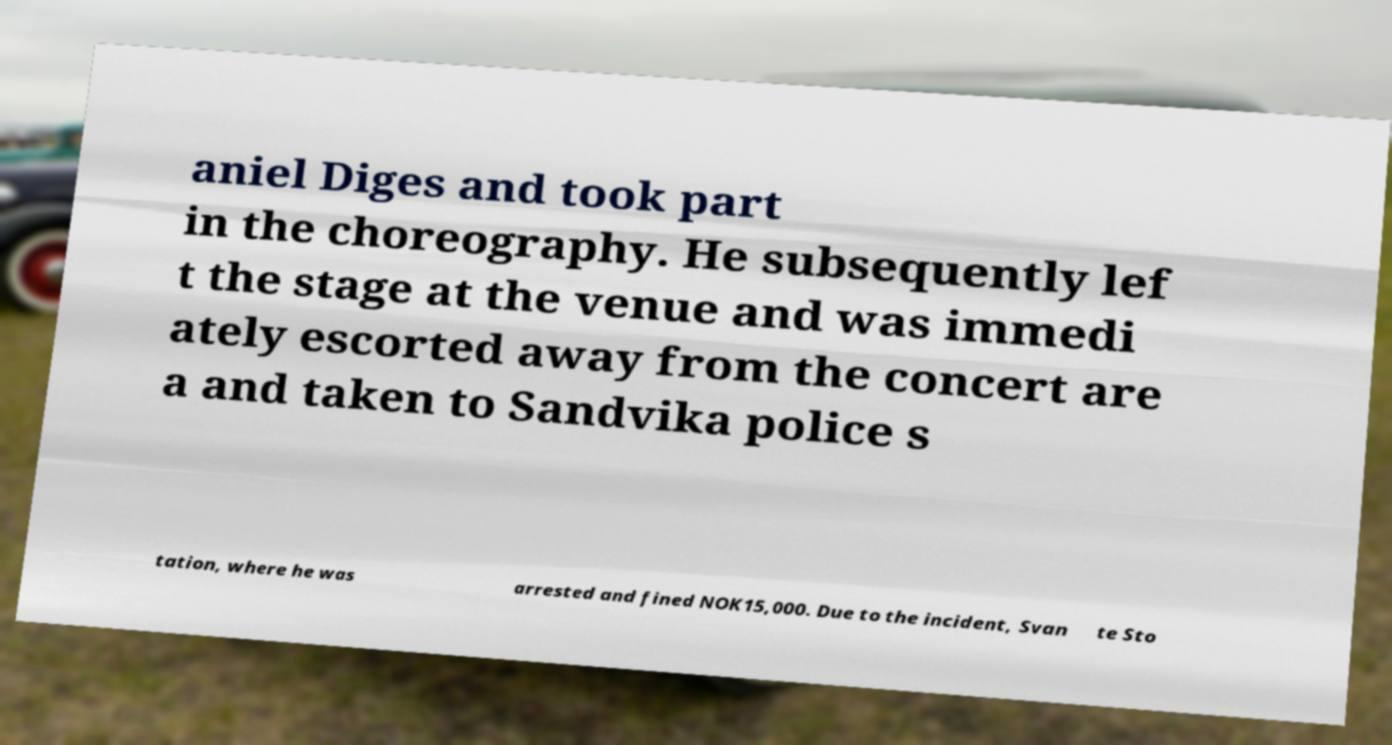There's text embedded in this image that I need extracted. Can you transcribe it verbatim? aniel Diges and took part in the choreography. He subsequently lef t the stage at the venue and was immedi ately escorted away from the concert are a and taken to Sandvika police s tation, where he was arrested and fined NOK15,000. Due to the incident, Svan te Sto 